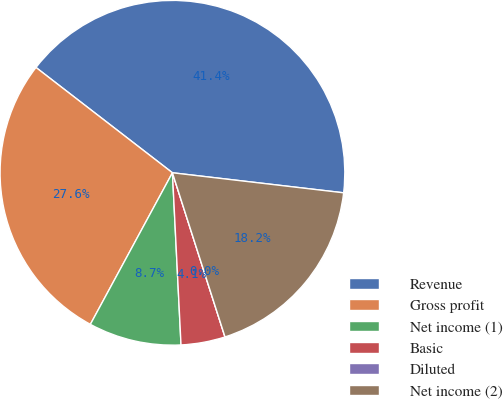Convert chart. <chart><loc_0><loc_0><loc_500><loc_500><pie_chart><fcel>Revenue<fcel>Gross profit<fcel>Net income (1)<fcel>Basic<fcel>Diluted<fcel>Net income (2)<nl><fcel>41.39%<fcel>27.56%<fcel>8.69%<fcel>4.14%<fcel>0.0%<fcel>18.21%<nl></chart> 